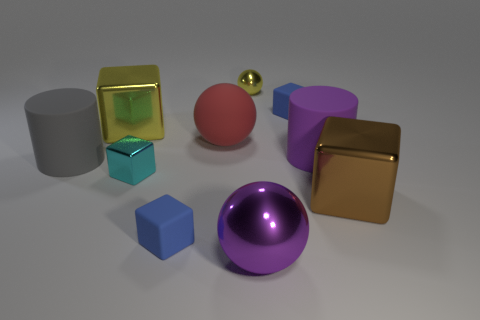Subtract all large yellow cubes. How many cubes are left? 4 Subtract all brown cubes. How many cubes are left? 4 Subtract all green cubes. Subtract all brown spheres. How many cubes are left? 5 Subtract all balls. How many objects are left? 7 Add 7 small green metal cylinders. How many small green metal cylinders exist? 7 Subtract 1 purple cylinders. How many objects are left? 9 Subtract all matte things. Subtract all big yellow metallic blocks. How many objects are left? 4 Add 2 big red matte things. How many big red matte things are left? 3 